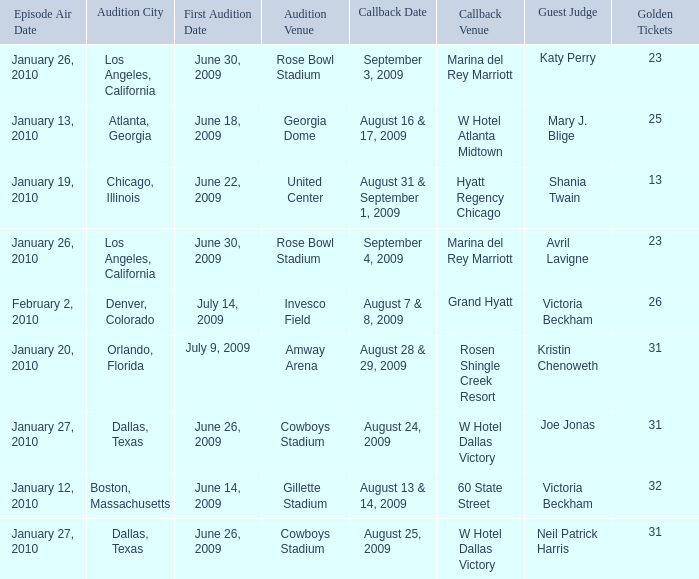Name the guest judge for first audition date being july 9, 2009 1.0. 